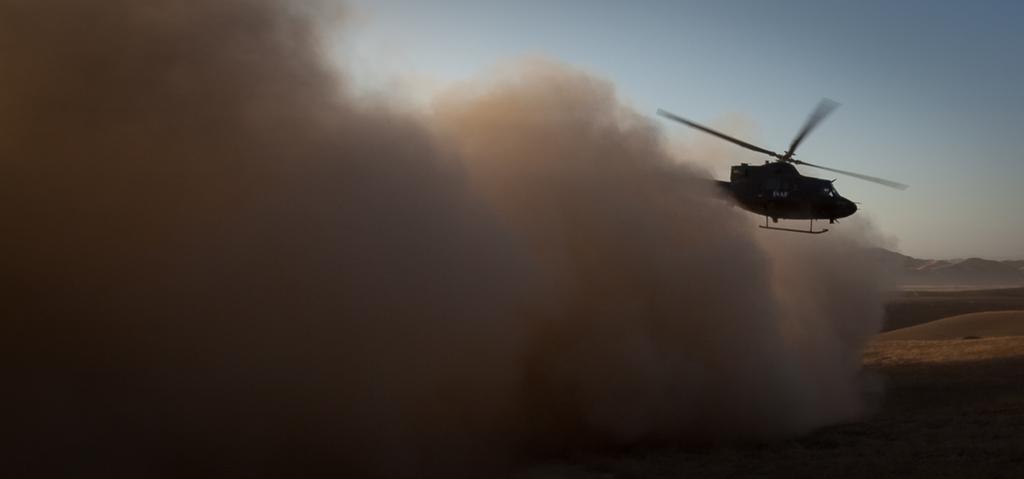Can you describe this image briefly? In this image I can see a helicopter which is black in color is flying in the air. I can see the ground, the dust, few mountains and the sky. 